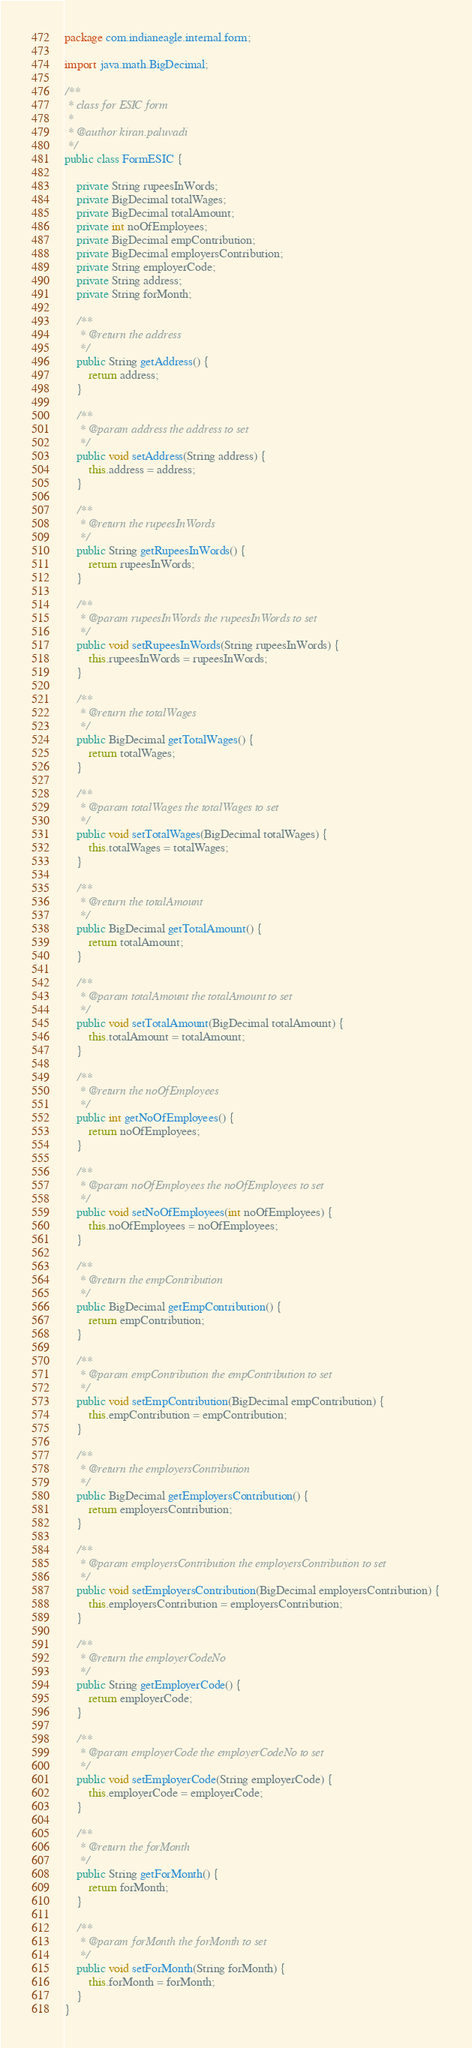Convert code to text. <code><loc_0><loc_0><loc_500><loc_500><_Java_>package com.indianeagle.internal.form;

import java.math.BigDecimal;

/**
 * class for ESIC form
 *
 * @author kiran.paluvadi
 */
public class FormESIC {

    private String rupeesInWords;
    private BigDecimal totalWages;
    private BigDecimal totalAmount;
    private int noOfEmployees;
    private BigDecimal empContribution;
    private BigDecimal employersContribution;
    private String employerCode;
    private String address;
    private String forMonth;

    /**
     * @return the address
     */
    public String getAddress() {
        return address;
    }

    /**
     * @param address the address to set
     */
    public void setAddress(String address) {
        this.address = address;
    }

    /**
     * @return the rupeesInWords
     */
    public String getRupeesInWords() {
        return rupeesInWords;
    }

    /**
     * @param rupeesInWords the rupeesInWords to set
     */
    public void setRupeesInWords(String rupeesInWords) {
        this.rupeesInWords = rupeesInWords;
    }

    /**
     * @return the totalWages
     */
    public BigDecimal getTotalWages() {
        return totalWages;
    }

    /**
     * @param totalWages the totalWages to set
     */
    public void setTotalWages(BigDecimal totalWages) {
        this.totalWages = totalWages;
    }

    /**
     * @return the totalAmount
     */
    public BigDecimal getTotalAmount() {
        return totalAmount;
    }

    /**
     * @param totalAmount the totalAmount to set
     */
    public void setTotalAmount(BigDecimal totalAmount) {
        this.totalAmount = totalAmount;
    }

    /**
     * @return the noOfEmployees
     */
    public int getNoOfEmployees() {
        return noOfEmployees;
    }

    /**
     * @param noOfEmployees the noOfEmployees to set
     */
    public void setNoOfEmployees(int noOfEmployees) {
        this.noOfEmployees = noOfEmployees;
    }

    /**
     * @return the empContribution
     */
    public BigDecimal getEmpContribution() {
        return empContribution;
    }

    /**
     * @param empContribution the empContribution to set
     */
    public void setEmpContribution(BigDecimal empContribution) {
        this.empContribution = empContribution;
    }

    /**
     * @return the employersContribution
     */
    public BigDecimal getEmployersContribution() {
        return employersContribution;
    }

    /**
     * @param employersContribution the employersContribution to set
     */
    public void setEmployersContribution(BigDecimal employersContribution) {
        this.employersContribution = employersContribution;
    }

    /**
     * @return the employerCodeNo
     */
    public String getEmployerCode() {
        return employerCode;
    }

    /**
     * @param employerCode the employerCodeNo to set
     */
    public void setEmployerCode(String employerCode) {
        this.employerCode = employerCode;
    }

    /**
     * @return the forMonth
     */
    public String getForMonth() {
        return forMonth;
    }

    /**
     * @param forMonth the forMonth to set
     */
    public void setForMonth(String forMonth) {
        this.forMonth = forMonth;
    }
}
</code> 